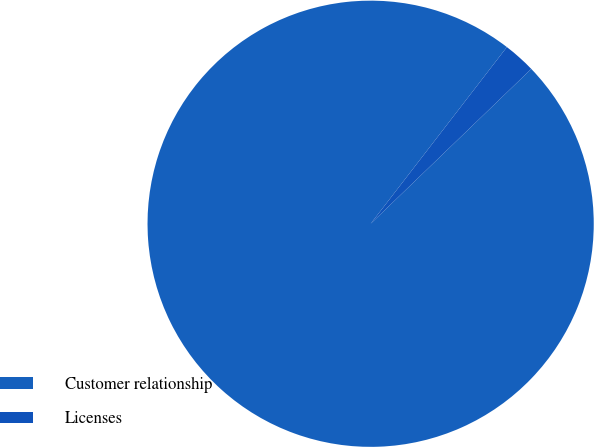Convert chart to OTSL. <chart><loc_0><loc_0><loc_500><loc_500><pie_chart><fcel>Customer relationship<fcel>Licenses<nl><fcel>97.66%<fcel>2.34%<nl></chart> 